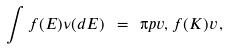Convert formula to latex. <formula><loc_0><loc_0><loc_500><loc_500>\int f ( E ) \nu ( d E ) \ = \ \i p { v , f ( K ) v } \, ,</formula> 